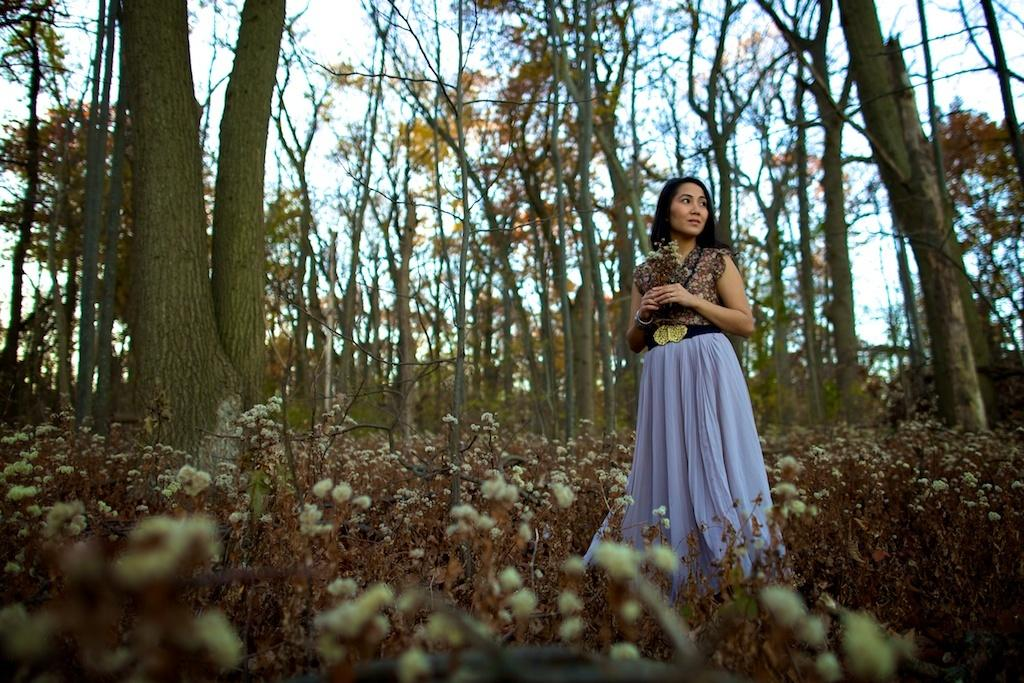What is the main subject in the image? There is a woman standing in the image. What other elements can be seen in the image besides the woman? There are multiple plants in the image. What can be seen in the background of the image? There are trees visible in the background of the image. What is visible above the trees in the image? The sky is visible in the image. How many degrees are the boys wearing in the image? There are no boys or degrees present in the image. What type of tent can be seen in the image? There is no tent present in the image. 